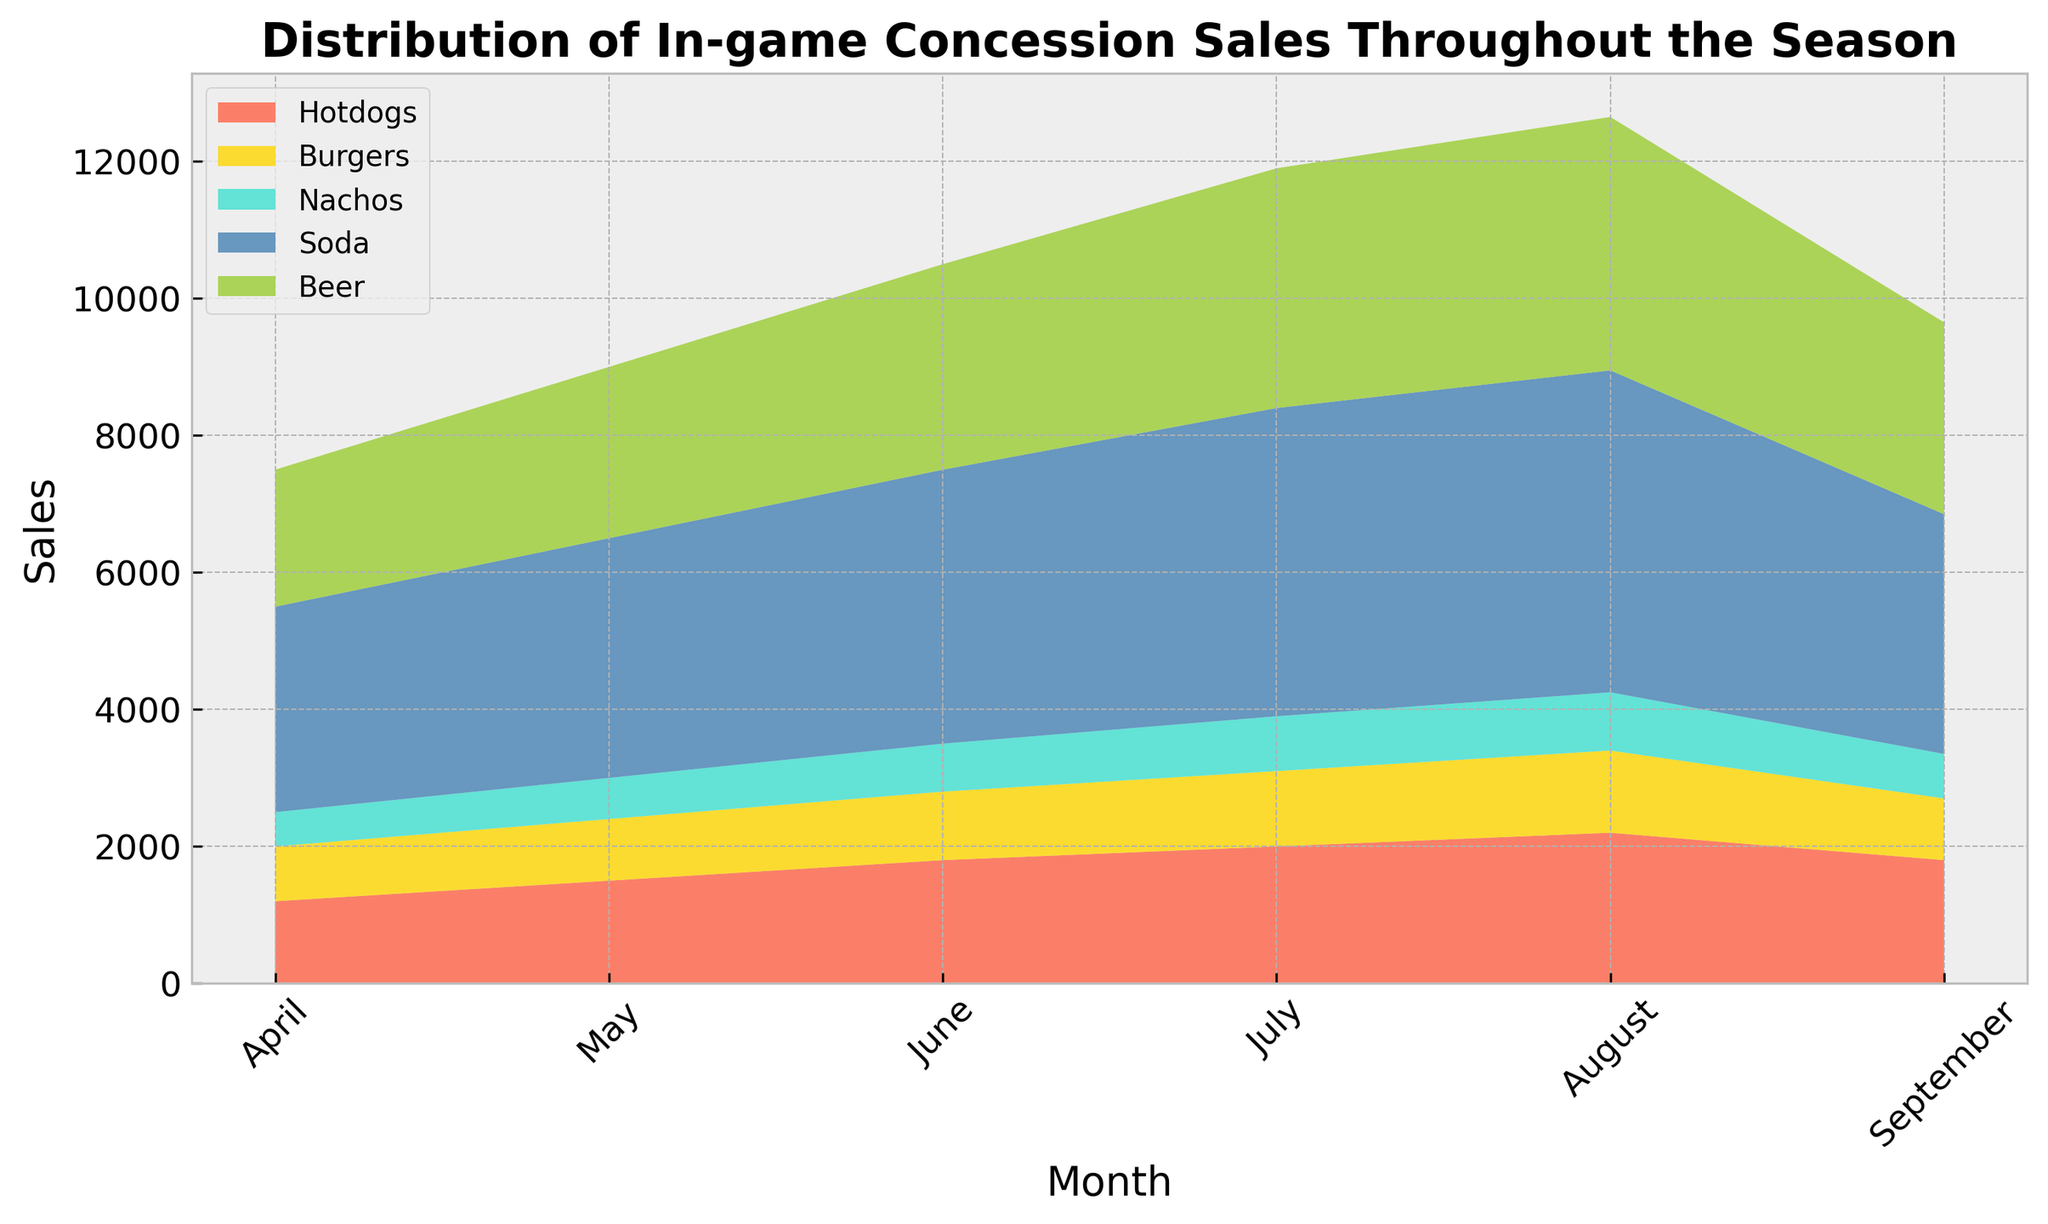What is the total sales figure for hotdogs in the chart? Sum up the monthly sales figures for hotdogs: 1200 (April) + 1500 (May) + 1800 (June) + 2000 (July) + 2200 (August) + 1800 (September). The total sales figure is thus 1200 + 1500 + 1800 + 2000 + 2200 + 1800 = 10500.
Answer: 10500 Which month had the peak sales for both soda and beer combined? Check the combined sales of soda and beer for each month. April: 3000 + 2000 = 5000, May: 3500 + 2500 = 6000, June: 4000 + 3000 = 7000, July: 4500 + 3500 = 8000, August: 4700 + 3700 = 8400, September: 3500 + 2800 = 6300. August has the highest combined sales of soda and beer.
Answer: August In which month did nachos sales surpass soda sales for the first time? Compare nachos and soda sales month by month: April (500 vs. 3000), May (600 vs. 3500), June (700 vs. 4000), July (800 vs. 4500), August (850 vs. 4700), September (650 vs. 3500). Nachos sales never surpass soda sales in any month.
Answer: Never Compare the sales of burgers and hotdogs in July. Which one is higher and by how much? Look at July's sales figures: Hotdogs = 2000, Burgers = 1100. Hotdogs are higher, and the difference is 2000 - 1100 = 900.
Answer: Hotdogs, 900 What is the average monthly sales figure for beer? Sum up the monthly sales figures for beer: 2000 (April) + 2500 (May) + 3000 (June) + 3500 (July) + 3700 (August) + 2800 (September), which equals 17500. Then divide by the number of months (6). 17500 / 6 = 2916.67 (rounded to two decimal places).
Answer: 2916.67 Identify the month with the lowest burger sales. Check the sales for each month: April (800), May (900), June (1000), July (1100), August (1200), September (900). April has the lowest burger sales with 800.
Answer: April 